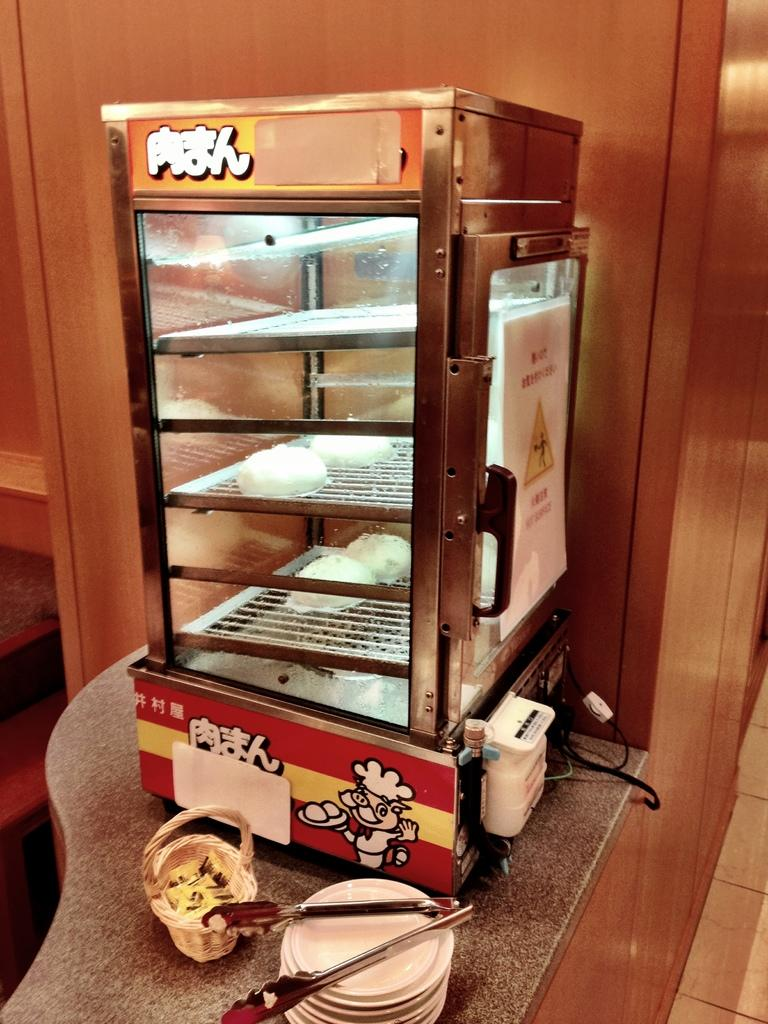What type of furniture is present in the image? There is a cabinet in the image. What is placed on top of the cabinet? There is a refrigerator on the cabinet. What else can be seen on the cabinet? There is a basket and tongs on the cabinet. How are the serving plates arranged on the cabinet? The serving plates are on racks on the cabinet. What type of humor can be seen in the image? There is no humor present in the image; it is a picture of a cabinet with various items on it. 